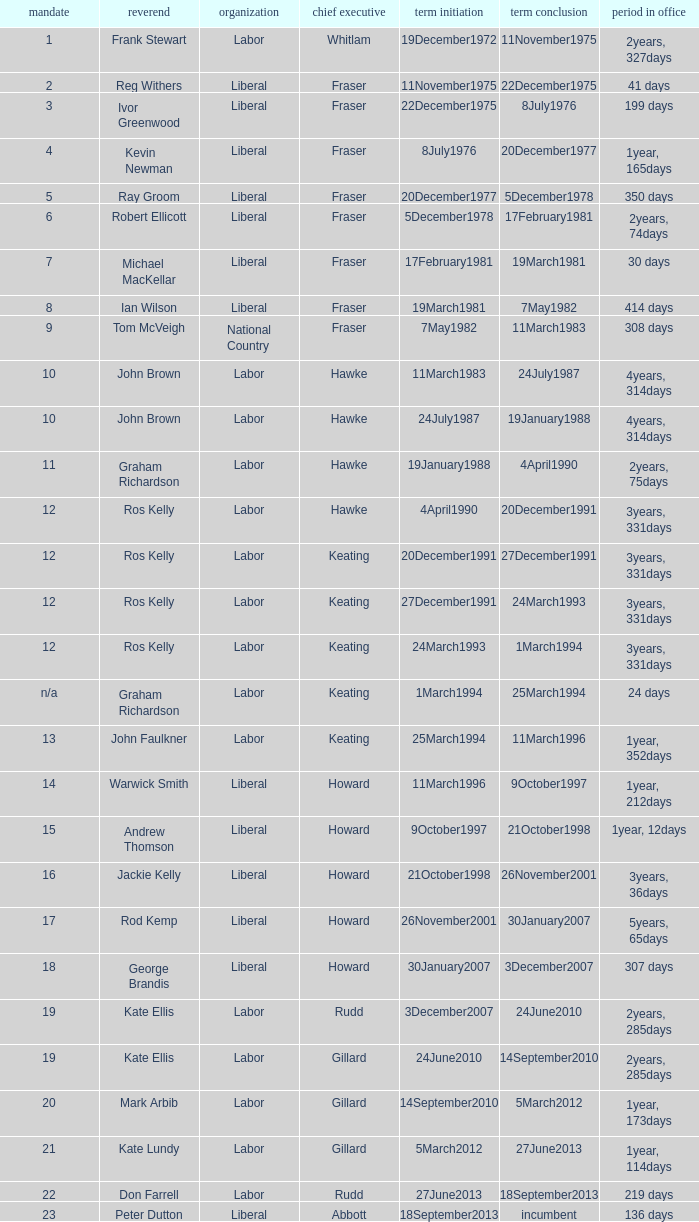What is the Term in office with an Order that is 9? 308 days. 